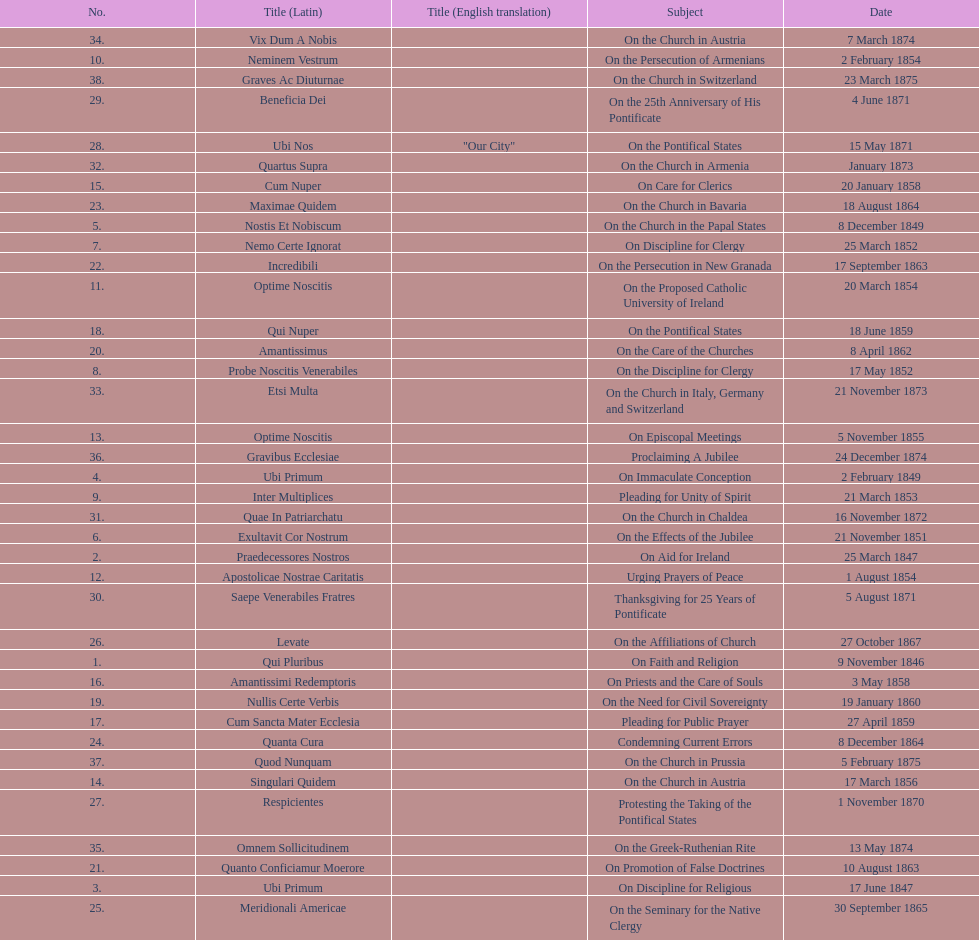How many areas of study are there? 38. Would you mind parsing the complete table? {'header': ['No.', 'Title (Latin)', 'Title (English translation)', 'Subject', 'Date'], 'rows': [['34.', 'Vix Dum A Nobis', '', 'On the Church in Austria', '7 March 1874'], ['10.', 'Neminem Vestrum', '', 'On the Persecution of Armenians', '2 February 1854'], ['38.', 'Graves Ac Diuturnae', '', 'On the Church in Switzerland', '23 March 1875'], ['29.', 'Beneficia Dei', '', 'On the 25th Anniversary of His Pontificate', '4 June 1871'], ['28.', 'Ubi Nos', '"Our City"', 'On the Pontifical States', '15 May 1871'], ['32.', 'Quartus Supra', '', 'On the Church in Armenia', 'January 1873'], ['15.', 'Cum Nuper', '', 'On Care for Clerics', '20 January 1858'], ['23.', 'Maximae Quidem', '', 'On the Church in Bavaria', '18 August 1864'], ['5.', 'Nostis Et Nobiscum', '', 'On the Church in the Papal States', '8 December 1849'], ['7.', 'Nemo Certe Ignorat', '', 'On Discipline for Clergy', '25 March 1852'], ['22.', 'Incredibili', '', 'On the Persecution in New Granada', '17 September 1863'], ['11.', 'Optime Noscitis', '', 'On the Proposed Catholic University of Ireland', '20 March 1854'], ['18.', 'Qui Nuper', '', 'On the Pontifical States', '18 June 1859'], ['20.', 'Amantissimus', '', 'On the Care of the Churches', '8 April 1862'], ['8.', 'Probe Noscitis Venerabiles', '', 'On the Discipline for Clergy', '17 May 1852'], ['33.', 'Etsi Multa', '', 'On the Church in Italy, Germany and Switzerland', '21 November 1873'], ['13.', 'Optime Noscitis', '', 'On Episcopal Meetings', '5 November 1855'], ['36.', 'Gravibus Ecclesiae', '', 'Proclaiming A Jubilee', '24 December 1874'], ['4.', 'Ubi Primum', '', 'On Immaculate Conception', '2 February 1849'], ['9.', 'Inter Multiplices', '', 'Pleading for Unity of Spirit', '21 March 1853'], ['31.', 'Quae In Patriarchatu', '', 'On the Church in Chaldea', '16 November 1872'], ['6.', 'Exultavit Cor Nostrum', '', 'On the Effects of the Jubilee', '21 November 1851'], ['2.', 'Praedecessores Nostros', '', 'On Aid for Ireland', '25 March 1847'], ['12.', 'Apostolicae Nostrae Caritatis', '', 'Urging Prayers of Peace', '1 August 1854'], ['30.', 'Saepe Venerabiles Fratres', '', 'Thanksgiving for 25 Years of Pontificate', '5 August 1871'], ['26.', 'Levate', '', 'On the Affiliations of Church', '27 October 1867'], ['1.', 'Qui Pluribus', '', 'On Faith and Religion', '9 November 1846'], ['16.', 'Amantissimi Redemptoris', '', 'On Priests and the Care of Souls', '3 May 1858'], ['19.', 'Nullis Certe Verbis', '', 'On the Need for Civil Sovereignty', '19 January 1860'], ['17.', 'Cum Sancta Mater Ecclesia', '', 'Pleading for Public Prayer', '27 April 1859'], ['24.', 'Quanta Cura', '', 'Condemning Current Errors', '8 December 1864'], ['37.', 'Quod Nunquam', '', 'On the Church in Prussia', '5 February 1875'], ['14.', 'Singulari Quidem', '', 'On the Church in Austria', '17 March 1856'], ['27.', 'Respicientes', '', 'Protesting the Taking of the Pontifical States', '1 November 1870'], ['35.', 'Omnem Sollicitudinem', '', 'On the Greek-Ruthenian Rite', '13 May 1874'], ['21.', 'Quanto Conficiamur Moerore', '', 'On Promotion of False Doctrines', '10 August 1863'], ['3.', 'Ubi Primum', '', 'On Discipline for Religious', '17 June 1847'], ['25.', 'Meridionali Americae', '', 'On the Seminary for the Native Clergy', '30 September 1865']]} 